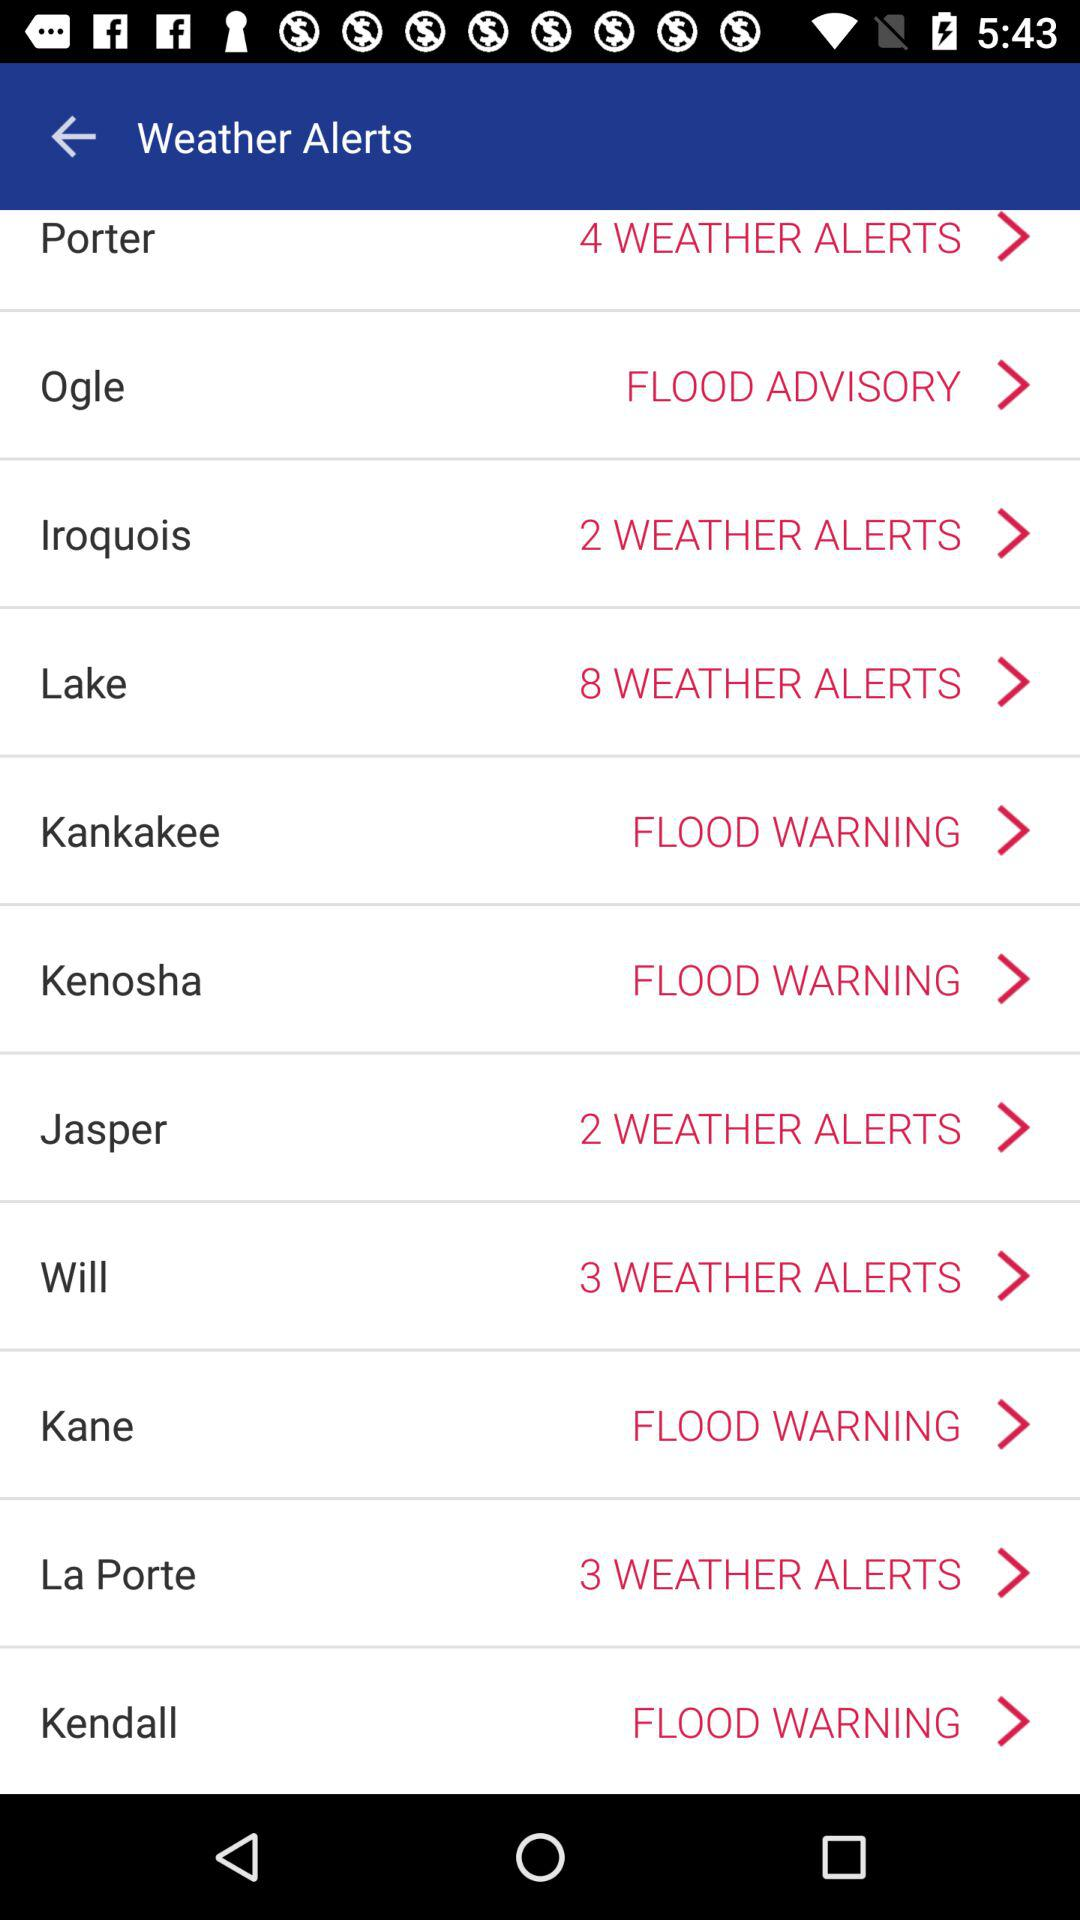Which county has the most weather alerts?
Answer the question using a single word or phrase. Lake 